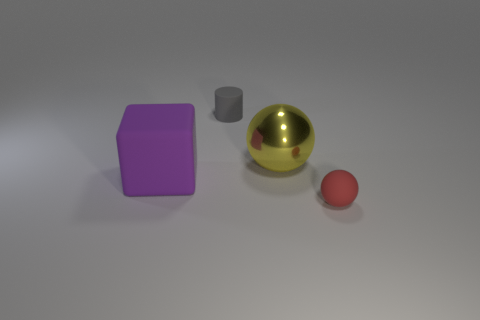Subtract all red balls. How many balls are left? 1 Subtract 1 cubes. How many cubes are left? 0 Subtract all blocks. How many objects are left? 3 Add 3 large objects. How many objects exist? 7 Subtract 1 purple cubes. How many objects are left? 3 Subtract all brown cubes. Subtract all gray spheres. How many cubes are left? 1 Subtract all brown blocks. How many gray spheres are left? 0 Subtract all small gray rubber objects. Subtract all tiny red spheres. How many objects are left? 2 Add 3 tiny gray rubber objects. How many tiny gray rubber objects are left? 4 Add 2 tiny gray rubber cylinders. How many tiny gray rubber cylinders exist? 3 